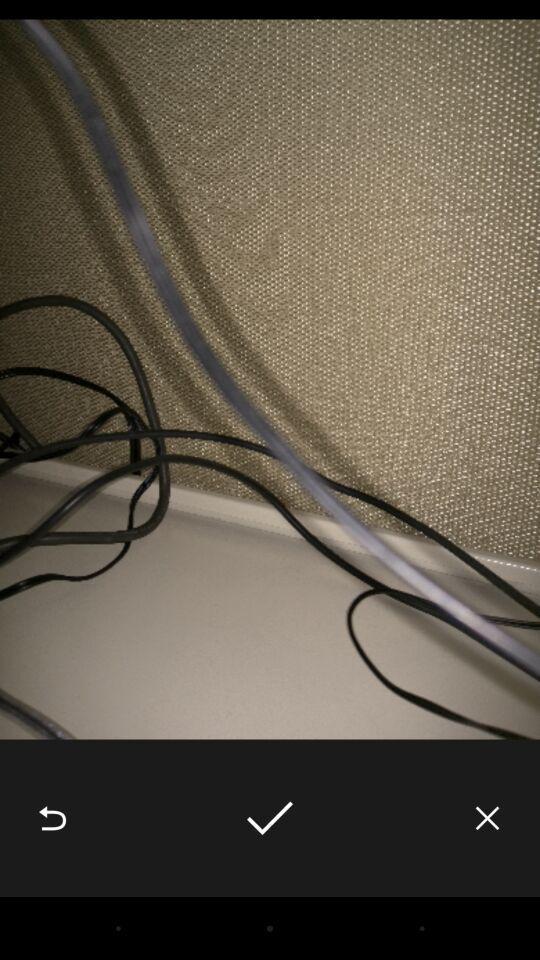What can you discern from this picture? Window displaying an image with wires. 